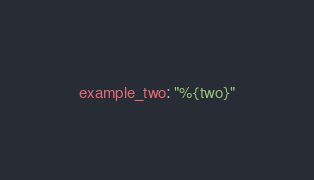<code> <loc_0><loc_0><loc_500><loc_500><_YAML_>example_two: "%{two}"
</code> 